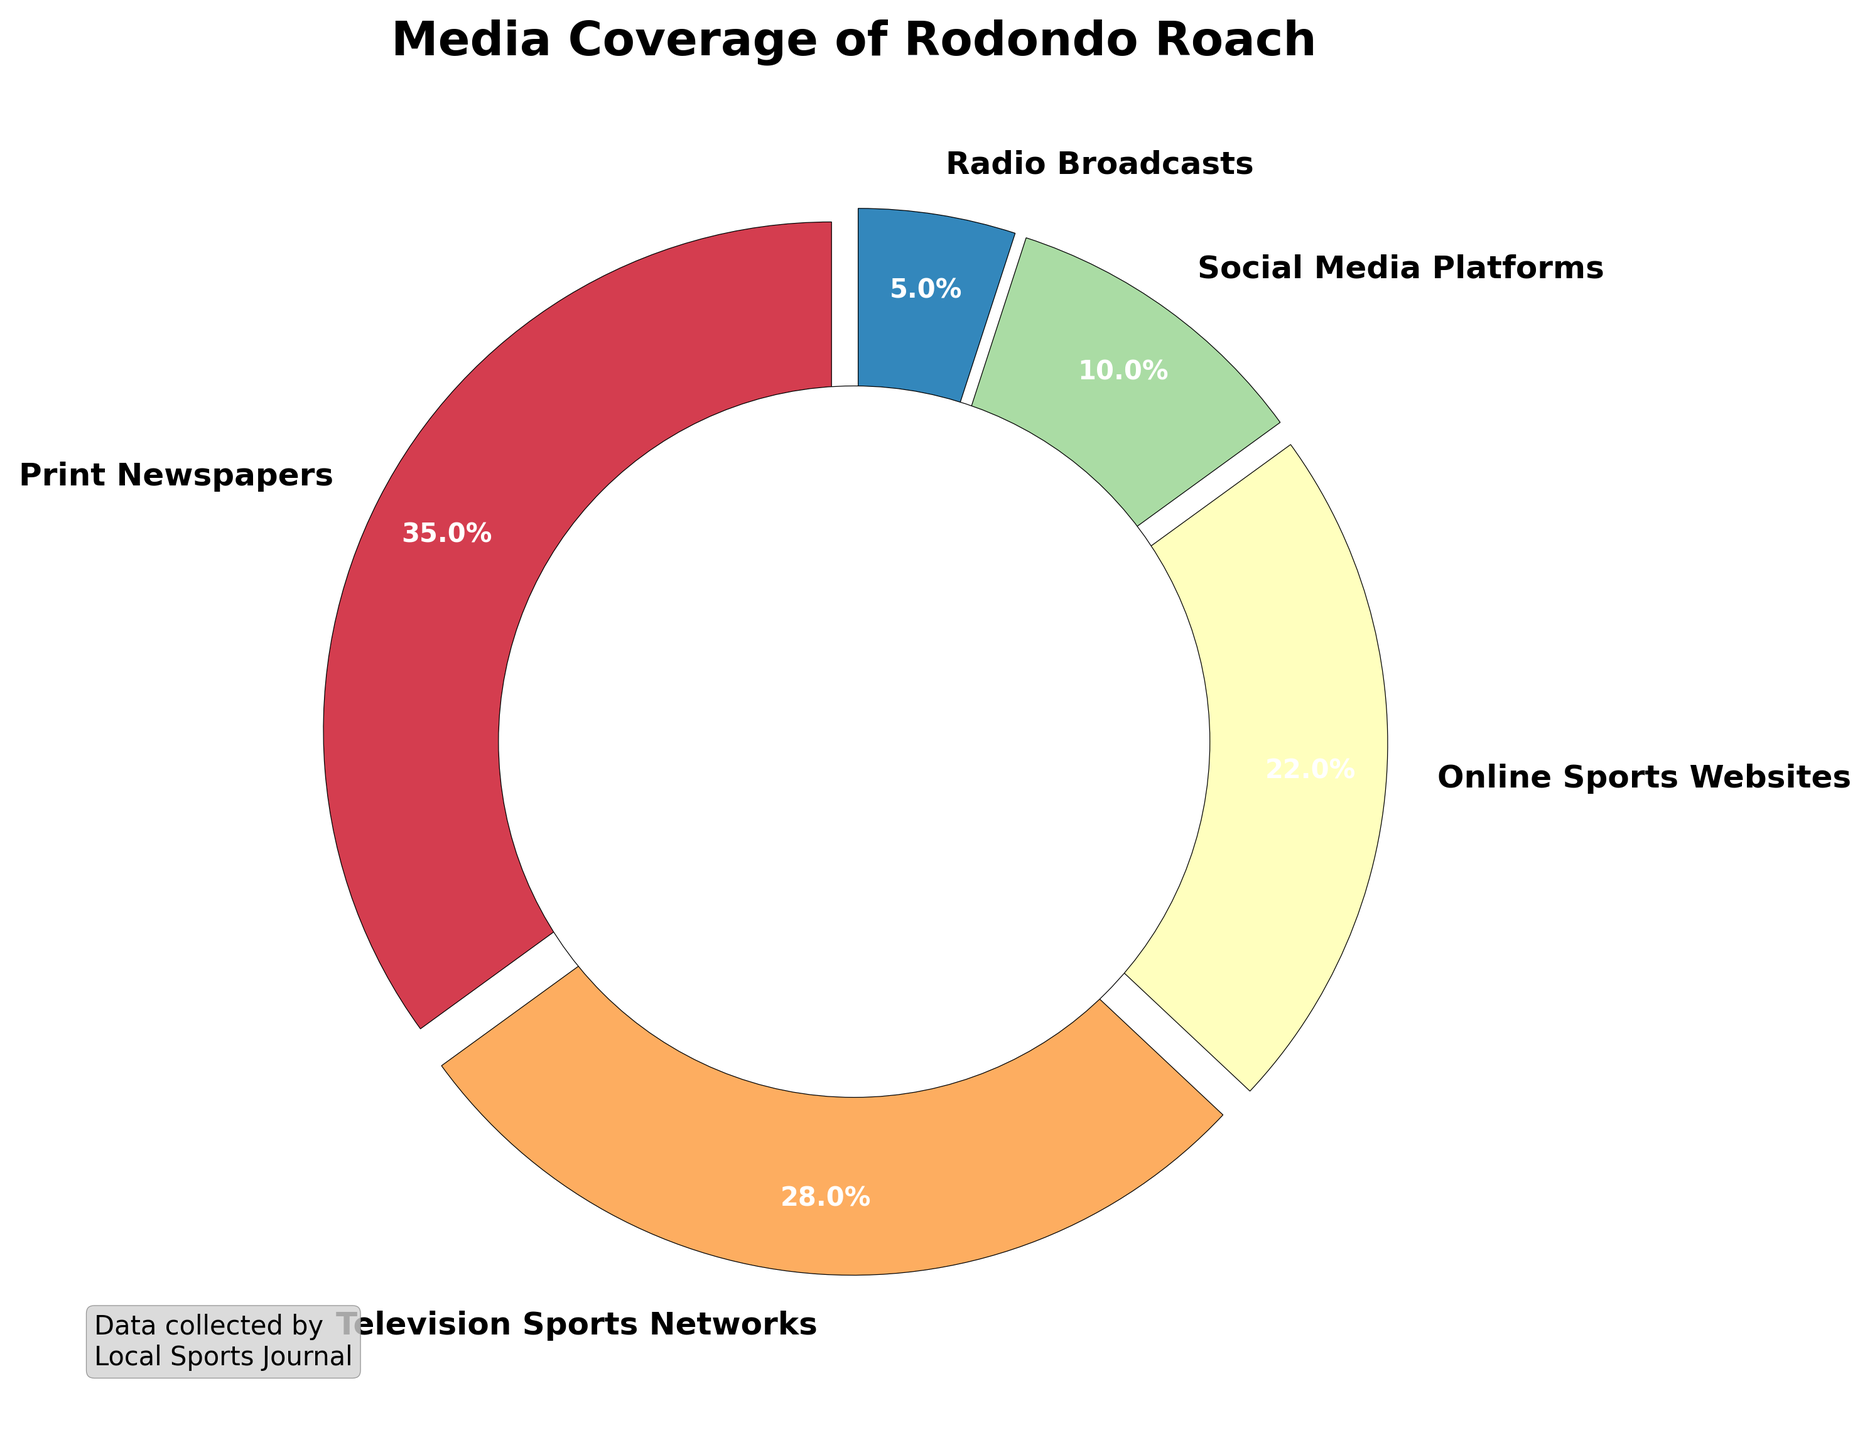What percentage of media coverage featuring Rodondo Roach is through Television Sports Networks? The segment labeled "Television Sports Networks" shows 28%. This is directly readable from the pie chart.
Answer: 28% What is the combined percentage of media coverage from Print Newspapers and Online Sports Websites? Print Newspapers account for 35% and Online Sports Websites account for 22%. Adding these together: 35% + 22% = 57%.
Answer: 57% Which media type has the smallest proportion of coverage featuring Rodondo Roach? The smallest segment on the pie chart is labeled "Radio Broadcasts," which shows 5%.
Answer: Radio Broadcasts How much more coverage does Print Newspapers have compared to Social Media Platforms? Print Newspapers cover 35%, while Social Media Platforms cover 10%. The difference is 35% - 10% = 25%.
Answer: 25% What is the proportion of media coverage from sources other than Television Sports Networks and Print Newspapers? First, add the percentages of Television Sports Networks and Print Newspapers: 28% + 35% = 63%. Subtract this from 100%: 100% - 63% = 37%.
Answer: 37% If the coverage from Social Media Platforms doubles, what would be the new total percentage for Social Media Platforms? If the original coverage from Social Media Platforms is 10%, doubling it would be 10% x 2 = 20%.
Answer: 20% Is the combined media coverage from traditional media (Print Newspapers, Television Sports Networks, Radio Broadcasts) greater than the combined coverage from digital media (Online Sports Websites, Social Media Platforms)? Traditional media add up to: 35% (Print) + 28% (TV) + 5% (Radio) = 68%. Digital media add up to: 22% (Online) + 10% (Social) = 32%. 68% > 32%.
Answer: Yes By what factor is the coverage from Television Sports Networks greater than that from Radio Broadcasts? Television Sports Networks cover 28% while Radio Broadcasts cover 5%. The factor is 28% / 5% = 5.6.
Answer: 5.6 Which segment—Online Sports Websites or Social Media Platforms—has a visually larger area in the pie chart? The section labeled "Online Sports Websites" is larger than the section labeled "Social Media Platforms" which is indicated by the percentages 22% for Online Sports Websites versus 10% for Social Media Platforms.
Answer: Online Sports Websites What is the average percentage coverage across all the media types? The percentages are: 35%, 28%, 22%, 10%, and 5%. Adding them gives 35 + 28 + 22 + 10 + 5 = 100%. There are 5 data points, so the average is 100% / 5 = 20%.
Answer: 20% 